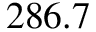Convert formula to latex. <formula><loc_0><loc_0><loc_500><loc_500>2 8 6 . 7</formula> 